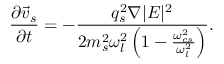Convert formula to latex. <formula><loc_0><loc_0><loc_500><loc_500>\frac { \partial \vec { v } _ { s } } { \partial t } = - \frac { q _ { s } ^ { 2 } \nabla | E | ^ { 2 } } { 2 m _ { s } ^ { 2 } \omega _ { l } ^ { 2 } \left ( 1 - \frac { \omega _ { c s } ^ { 2 } } { \omega _ { l } ^ { 2 } } \right ) } .</formula> 